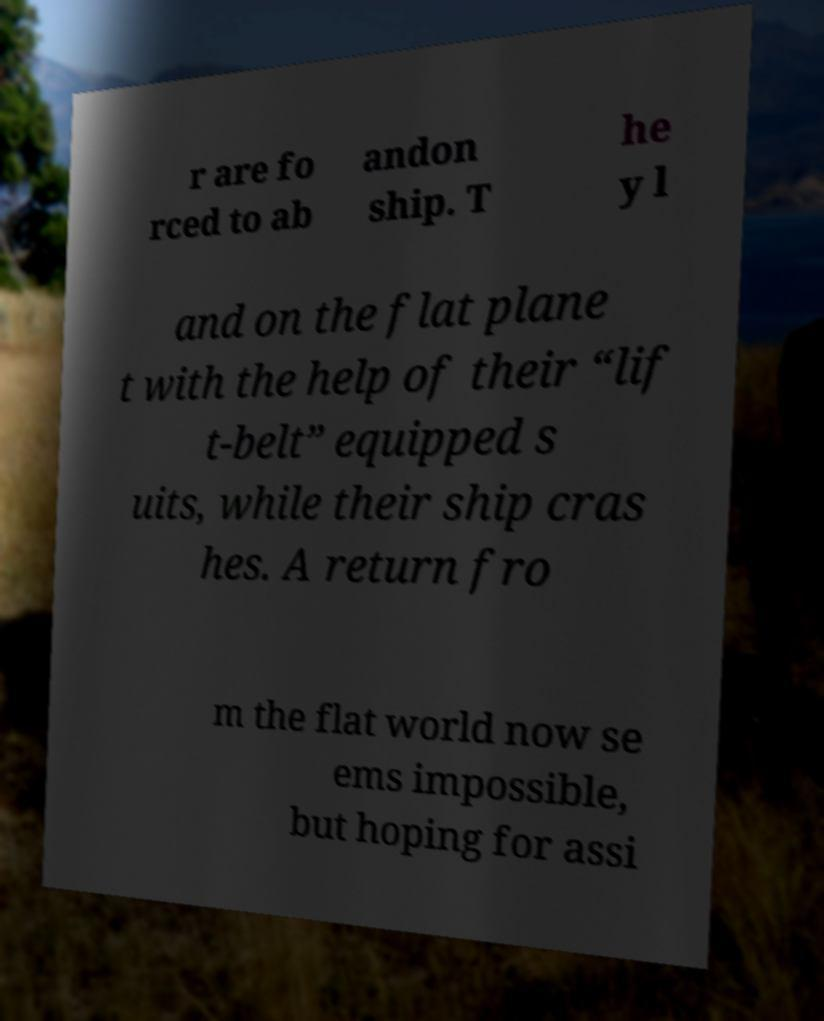Please read and relay the text visible in this image. What does it say? r are fo rced to ab andon ship. T he y l and on the flat plane t with the help of their “lif t-belt” equipped s uits, while their ship cras hes. A return fro m the flat world now se ems impossible, but hoping for assi 